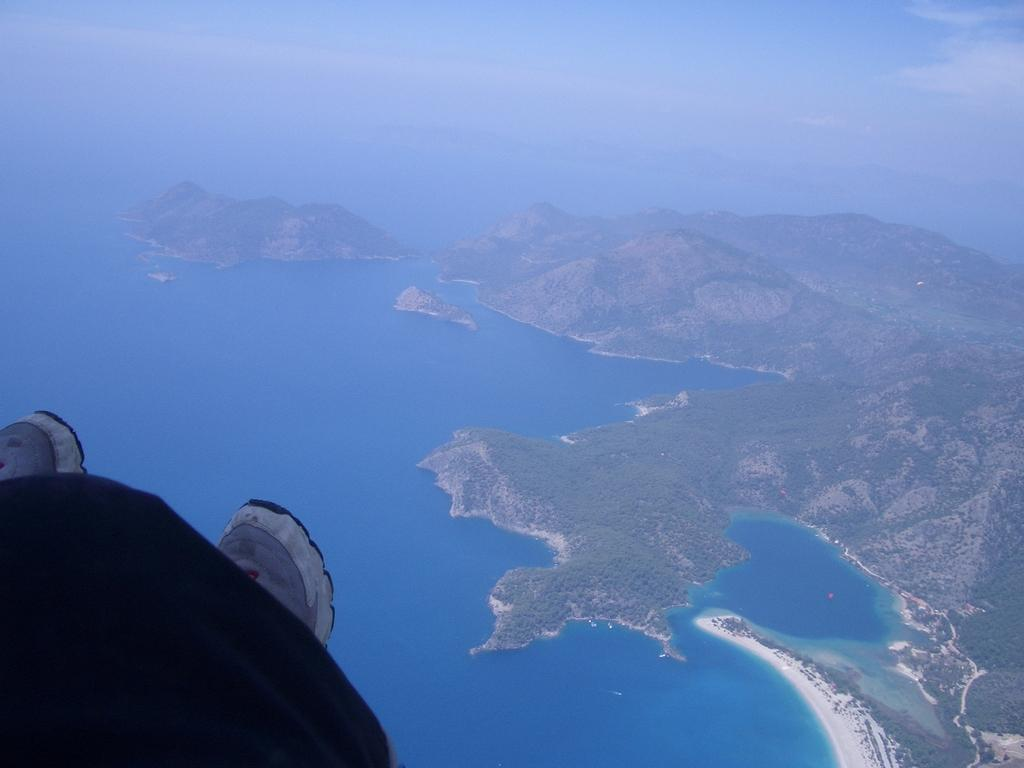What objects are located at the bottom left side of the image? There is a cloth and shoes at the bottom left side of the image. What can be seen in the background of the image? Sky, hills, and water are visible in the background of the image. How does the stomach of the person in the image feel after eating a large meal? There is no person present in the image, so it is not possible to determine how their stomach feels after eating a large meal. 